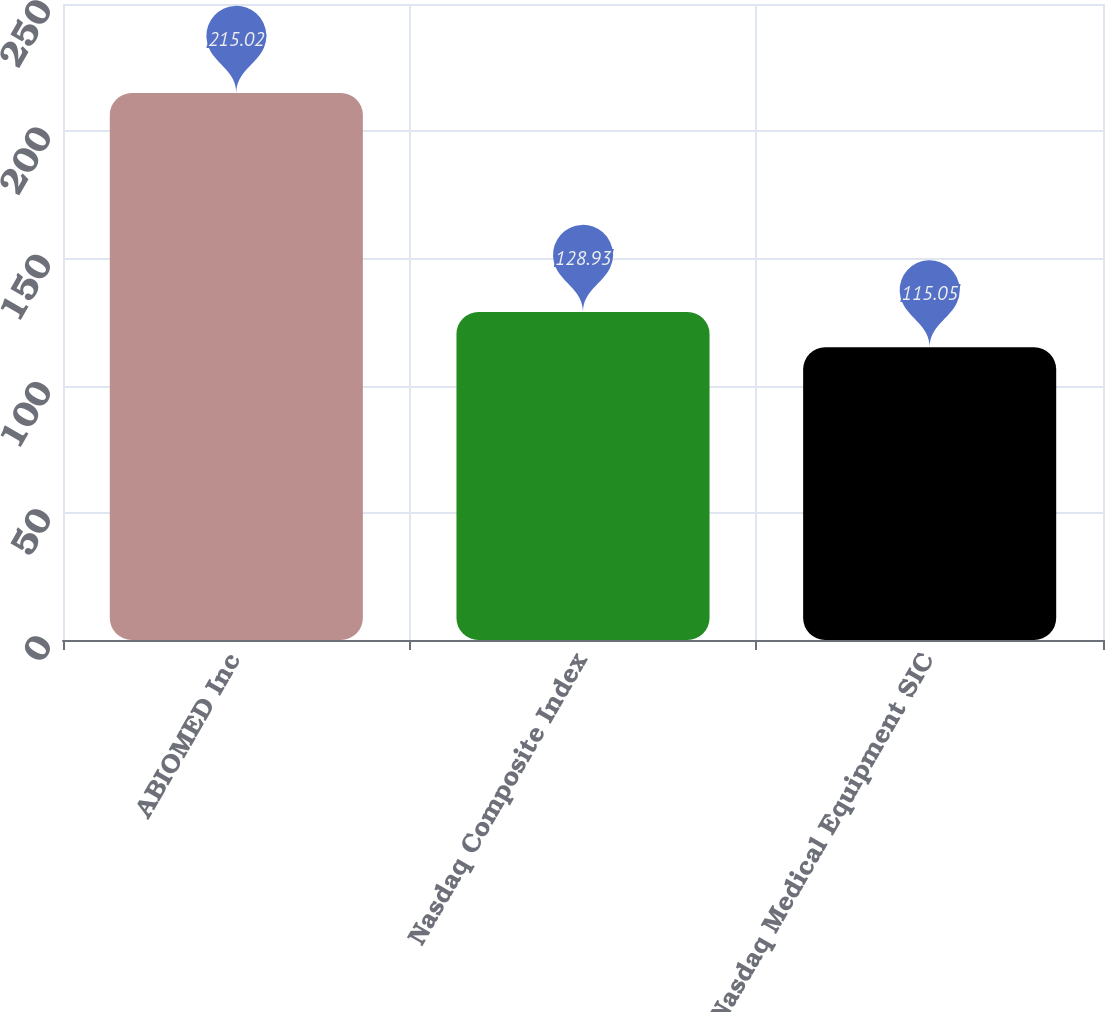Convert chart to OTSL. <chart><loc_0><loc_0><loc_500><loc_500><bar_chart><fcel>ABIOMED Inc<fcel>Nasdaq Composite Index<fcel>Nasdaq Medical Equipment SIC<nl><fcel>215.02<fcel>128.93<fcel>115.05<nl></chart> 